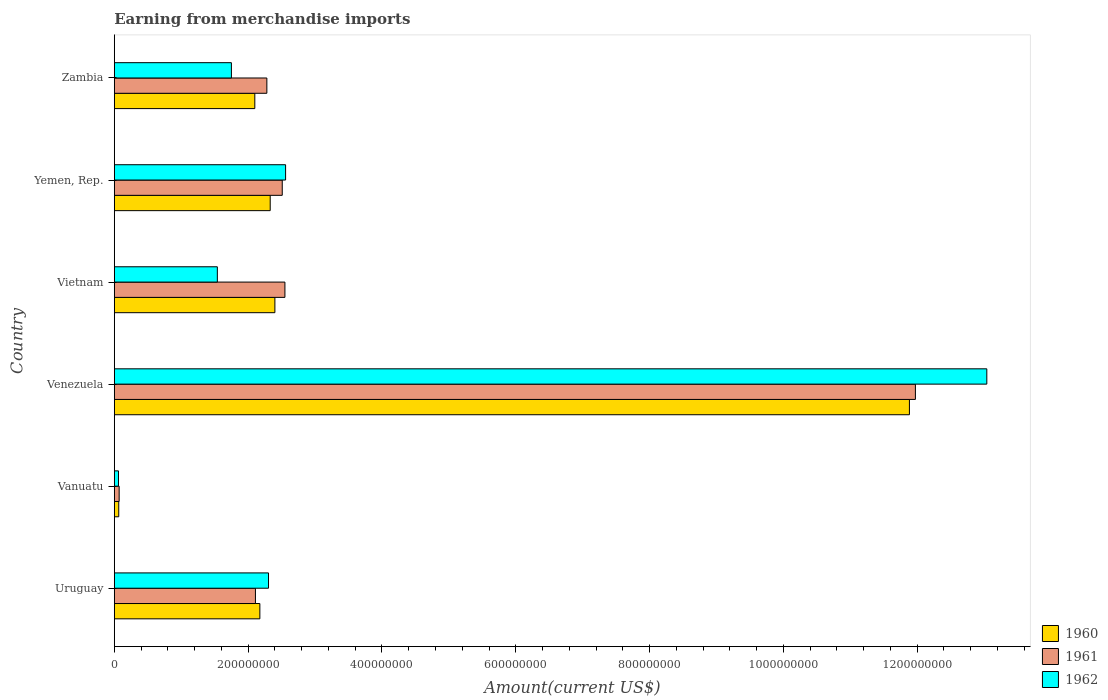How many groups of bars are there?
Your answer should be compact. 6. How many bars are there on the 4th tick from the top?
Your answer should be very brief. 3. What is the label of the 6th group of bars from the top?
Ensure brevity in your answer.  Uruguay. In how many cases, is the number of bars for a given country not equal to the number of legend labels?
Your response must be concise. 0. What is the amount earned from merchandise imports in 1962 in Vanuatu?
Offer a very short reply. 6.24e+06. Across all countries, what is the maximum amount earned from merchandise imports in 1961?
Keep it short and to the point. 1.20e+09. Across all countries, what is the minimum amount earned from merchandise imports in 1961?
Offer a very short reply. 7.25e+06. In which country was the amount earned from merchandise imports in 1961 maximum?
Your answer should be compact. Venezuela. In which country was the amount earned from merchandise imports in 1962 minimum?
Your answer should be compact. Vanuatu. What is the total amount earned from merchandise imports in 1962 in the graph?
Offer a terse response. 2.13e+09. What is the difference between the amount earned from merchandise imports in 1961 in Vietnam and that in Zambia?
Your response must be concise. 2.70e+07. What is the difference between the amount earned from merchandise imports in 1961 in Vietnam and the amount earned from merchandise imports in 1960 in Uruguay?
Make the answer very short. 3.75e+07. What is the average amount earned from merchandise imports in 1961 per country?
Your response must be concise. 3.58e+08. What is the difference between the amount earned from merchandise imports in 1960 and amount earned from merchandise imports in 1962 in Vanuatu?
Keep it short and to the point. 4.04e+05. In how many countries, is the amount earned from merchandise imports in 1962 greater than 240000000 US$?
Ensure brevity in your answer.  2. What is the ratio of the amount earned from merchandise imports in 1960 in Uruguay to that in Venezuela?
Offer a terse response. 0.18. Is the difference between the amount earned from merchandise imports in 1960 in Vanuatu and Vietnam greater than the difference between the amount earned from merchandise imports in 1962 in Vanuatu and Vietnam?
Your answer should be compact. No. What is the difference between the highest and the second highest amount earned from merchandise imports in 1962?
Your answer should be compact. 1.05e+09. What is the difference between the highest and the lowest amount earned from merchandise imports in 1961?
Offer a very short reply. 1.19e+09. In how many countries, is the amount earned from merchandise imports in 1962 greater than the average amount earned from merchandise imports in 1962 taken over all countries?
Provide a succinct answer. 1. What does the 3rd bar from the top in Venezuela represents?
Provide a short and direct response. 1960. Is it the case that in every country, the sum of the amount earned from merchandise imports in 1962 and amount earned from merchandise imports in 1960 is greater than the amount earned from merchandise imports in 1961?
Make the answer very short. Yes. Are all the bars in the graph horizontal?
Provide a succinct answer. Yes. What is the difference between two consecutive major ticks on the X-axis?
Make the answer very short. 2.00e+08. Are the values on the major ticks of X-axis written in scientific E-notation?
Offer a terse response. No. Does the graph contain any zero values?
Ensure brevity in your answer.  No. Does the graph contain grids?
Offer a very short reply. No. How are the legend labels stacked?
Offer a terse response. Vertical. What is the title of the graph?
Ensure brevity in your answer.  Earning from merchandise imports. Does "1986" appear as one of the legend labels in the graph?
Ensure brevity in your answer.  No. What is the label or title of the X-axis?
Make the answer very short. Amount(current US$). What is the Amount(current US$) in 1960 in Uruguay?
Keep it short and to the point. 2.18e+08. What is the Amount(current US$) in 1961 in Uruguay?
Your answer should be compact. 2.11e+08. What is the Amount(current US$) of 1962 in Uruguay?
Offer a terse response. 2.30e+08. What is the Amount(current US$) of 1960 in Vanuatu?
Provide a succinct answer. 6.64e+06. What is the Amount(current US$) in 1961 in Vanuatu?
Keep it short and to the point. 7.25e+06. What is the Amount(current US$) in 1962 in Vanuatu?
Your response must be concise. 6.24e+06. What is the Amount(current US$) of 1960 in Venezuela?
Keep it short and to the point. 1.19e+09. What is the Amount(current US$) of 1961 in Venezuela?
Offer a terse response. 1.20e+09. What is the Amount(current US$) in 1962 in Venezuela?
Give a very brief answer. 1.30e+09. What is the Amount(current US$) of 1960 in Vietnam?
Your response must be concise. 2.40e+08. What is the Amount(current US$) of 1961 in Vietnam?
Provide a short and direct response. 2.55e+08. What is the Amount(current US$) in 1962 in Vietnam?
Your answer should be very brief. 1.54e+08. What is the Amount(current US$) in 1960 in Yemen, Rep.?
Offer a terse response. 2.33e+08. What is the Amount(current US$) of 1961 in Yemen, Rep.?
Your answer should be very brief. 2.51e+08. What is the Amount(current US$) of 1962 in Yemen, Rep.?
Offer a very short reply. 2.56e+08. What is the Amount(current US$) in 1960 in Zambia?
Your response must be concise. 2.10e+08. What is the Amount(current US$) in 1961 in Zambia?
Give a very brief answer. 2.28e+08. What is the Amount(current US$) in 1962 in Zambia?
Keep it short and to the point. 1.75e+08. Across all countries, what is the maximum Amount(current US$) of 1960?
Offer a very short reply. 1.19e+09. Across all countries, what is the maximum Amount(current US$) of 1961?
Provide a short and direct response. 1.20e+09. Across all countries, what is the maximum Amount(current US$) in 1962?
Your answer should be compact. 1.30e+09. Across all countries, what is the minimum Amount(current US$) of 1960?
Your answer should be compact. 6.64e+06. Across all countries, what is the minimum Amount(current US$) of 1961?
Your response must be concise. 7.25e+06. Across all countries, what is the minimum Amount(current US$) in 1962?
Your answer should be compact. 6.24e+06. What is the total Amount(current US$) in 1960 in the graph?
Give a very brief answer. 2.10e+09. What is the total Amount(current US$) in 1961 in the graph?
Ensure brevity in your answer.  2.15e+09. What is the total Amount(current US$) in 1962 in the graph?
Ensure brevity in your answer.  2.13e+09. What is the difference between the Amount(current US$) in 1960 in Uruguay and that in Vanuatu?
Give a very brief answer. 2.11e+08. What is the difference between the Amount(current US$) of 1961 in Uruguay and that in Vanuatu?
Make the answer very short. 2.04e+08. What is the difference between the Amount(current US$) of 1962 in Uruguay and that in Vanuatu?
Your answer should be very brief. 2.24e+08. What is the difference between the Amount(current US$) of 1960 in Uruguay and that in Venezuela?
Your response must be concise. -9.71e+08. What is the difference between the Amount(current US$) in 1961 in Uruguay and that in Venezuela?
Ensure brevity in your answer.  -9.86e+08. What is the difference between the Amount(current US$) of 1962 in Uruguay and that in Venezuela?
Offer a very short reply. -1.07e+09. What is the difference between the Amount(current US$) of 1960 in Uruguay and that in Vietnam?
Ensure brevity in your answer.  -2.25e+07. What is the difference between the Amount(current US$) in 1961 in Uruguay and that in Vietnam?
Give a very brief answer. -4.41e+07. What is the difference between the Amount(current US$) in 1962 in Uruguay and that in Vietnam?
Keep it short and to the point. 7.65e+07. What is the difference between the Amount(current US$) of 1960 in Uruguay and that in Yemen, Rep.?
Your answer should be compact. -1.55e+07. What is the difference between the Amount(current US$) in 1961 in Uruguay and that in Yemen, Rep.?
Your response must be concise. -4.01e+07. What is the difference between the Amount(current US$) of 1962 in Uruguay and that in Yemen, Rep.?
Provide a short and direct response. -2.55e+07. What is the difference between the Amount(current US$) of 1960 in Uruguay and that in Zambia?
Offer a terse response. 7.54e+06. What is the difference between the Amount(current US$) in 1961 in Uruguay and that in Zambia?
Your answer should be compact. -1.71e+07. What is the difference between the Amount(current US$) of 1962 in Uruguay and that in Zambia?
Keep it short and to the point. 5.55e+07. What is the difference between the Amount(current US$) in 1960 in Vanuatu and that in Venezuela?
Keep it short and to the point. -1.18e+09. What is the difference between the Amount(current US$) in 1961 in Vanuatu and that in Venezuela?
Ensure brevity in your answer.  -1.19e+09. What is the difference between the Amount(current US$) of 1962 in Vanuatu and that in Venezuela?
Give a very brief answer. -1.30e+09. What is the difference between the Amount(current US$) in 1960 in Vanuatu and that in Vietnam?
Make the answer very short. -2.33e+08. What is the difference between the Amount(current US$) in 1961 in Vanuatu and that in Vietnam?
Your answer should be very brief. -2.48e+08. What is the difference between the Amount(current US$) of 1962 in Vanuatu and that in Vietnam?
Ensure brevity in your answer.  -1.48e+08. What is the difference between the Amount(current US$) of 1960 in Vanuatu and that in Yemen, Rep.?
Keep it short and to the point. -2.26e+08. What is the difference between the Amount(current US$) of 1961 in Vanuatu and that in Yemen, Rep.?
Provide a short and direct response. -2.44e+08. What is the difference between the Amount(current US$) of 1962 in Vanuatu and that in Yemen, Rep.?
Ensure brevity in your answer.  -2.50e+08. What is the difference between the Amount(current US$) of 1960 in Vanuatu and that in Zambia?
Your response must be concise. -2.03e+08. What is the difference between the Amount(current US$) of 1961 in Vanuatu and that in Zambia?
Your answer should be compact. -2.21e+08. What is the difference between the Amount(current US$) of 1962 in Vanuatu and that in Zambia?
Provide a succinct answer. -1.69e+08. What is the difference between the Amount(current US$) of 1960 in Venezuela and that in Vietnam?
Give a very brief answer. 9.48e+08. What is the difference between the Amount(current US$) of 1961 in Venezuela and that in Vietnam?
Offer a terse response. 9.42e+08. What is the difference between the Amount(current US$) in 1962 in Venezuela and that in Vietnam?
Keep it short and to the point. 1.15e+09. What is the difference between the Amount(current US$) of 1960 in Venezuela and that in Yemen, Rep.?
Offer a terse response. 9.55e+08. What is the difference between the Amount(current US$) of 1961 in Venezuela and that in Yemen, Rep.?
Provide a succinct answer. 9.46e+08. What is the difference between the Amount(current US$) of 1962 in Venezuela and that in Yemen, Rep.?
Ensure brevity in your answer.  1.05e+09. What is the difference between the Amount(current US$) in 1960 in Venezuela and that in Zambia?
Offer a very short reply. 9.78e+08. What is the difference between the Amount(current US$) of 1961 in Venezuela and that in Zambia?
Provide a succinct answer. 9.69e+08. What is the difference between the Amount(current US$) in 1962 in Venezuela and that in Zambia?
Ensure brevity in your answer.  1.13e+09. What is the difference between the Amount(current US$) in 1960 in Vietnam and that in Yemen, Rep.?
Offer a very short reply. 7.00e+06. What is the difference between the Amount(current US$) of 1961 in Vietnam and that in Yemen, Rep.?
Your answer should be very brief. 4.00e+06. What is the difference between the Amount(current US$) in 1962 in Vietnam and that in Yemen, Rep.?
Give a very brief answer. -1.02e+08. What is the difference between the Amount(current US$) of 1960 in Vietnam and that in Zambia?
Provide a succinct answer. 3.00e+07. What is the difference between the Amount(current US$) in 1961 in Vietnam and that in Zambia?
Your answer should be compact. 2.70e+07. What is the difference between the Amount(current US$) in 1962 in Vietnam and that in Zambia?
Keep it short and to the point. -2.10e+07. What is the difference between the Amount(current US$) in 1960 in Yemen, Rep. and that in Zambia?
Offer a terse response. 2.30e+07. What is the difference between the Amount(current US$) of 1961 in Yemen, Rep. and that in Zambia?
Offer a terse response. 2.30e+07. What is the difference between the Amount(current US$) in 1962 in Yemen, Rep. and that in Zambia?
Give a very brief answer. 8.10e+07. What is the difference between the Amount(current US$) of 1960 in Uruguay and the Amount(current US$) of 1961 in Vanuatu?
Your response must be concise. 2.10e+08. What is the difference between the Amount(current US$) of 1960 in Uruguay and the Amount(current US$) of 1962 in Vanuatu?
Your response must be concise. 2.11e+08. What is the difference between the Amount(current US$) of 1961 in Uruguay and the Amount(current US$) of 1962 in Vanuatu?
Your response must be concise. 2.05e+08. What is the difference between the Amount(current US$) of 1960 in Uruguay and the Amount(current US$) of 1961 in Venezuela?
Offer a terse response. -9.80e+08. What is the difference between the Amount(current US$) of 1960 in Uruguay and the Amount(current US$) of 1962 in Venezuela?
Provide a succinct answer. -1.09e+09. What is the difference between the Amount(current US$) of 1961 in Uruguay and the Amount(current US$) of 1962 in Venezuela?
Ensure brevity in your answer.  -1.09e+09. What is the difference between the Amount(current US$) of 1960 in Uruguay and the Amount(current US$) of 1961 in Vietnam?
Your answer should be very brief. -3.75e+07. What is the difference between the Amount(current US$) of 1960 in Uruguay and the Amount(current US$) of 1962 in Vietnam?
Give a very brief answer. 6.35e+07. What is the difference between the Amount(current US$) in 1961 in Uruguay and the Amount(current US$) in 1962 in Vietnam?
Keep it short and to the point. 5.69e+07. What is the difference between the Amount(current US$) in 1960 in Uruguay and the Amount(current US$) in 1961 in Yemen, Rep.?
Offer a terse response. -3.35e+07. What is the difference between the Amount(current US$) in 1960 in Uruguay and the Amount(current US$) in 1962 in Yemen, Rep.?
Ensure brevity in your answer.  -3.85e+07. What is the difference between the Amount(current US$) in 1961 in Uruguay and the Amount(current US$) in 1962 in Yemen, Rep.?
Ensure brevity in your answer.  -4.51e+07. What is the difference between the Amount(current US$) of 1960 in Uruguay and the Amount(current US$) of 1961 in Zambia?
Provide a succinct answer. -1.05e+07. What is the difference between the Amount(current US$) of 1960 in Uruguay and the Amount(current US$) of 1962 in Zambia?
Make the answer very short. 4.25e+07. What is the difference between the Amount(current US$) of 1961 in Uruguay and the Amount(current US$) of 1962 in Zambia?
Offer a terse response. 3.59e+07. What is the difference between the Amount(current US$) in 1960 in Vanuatu and the Amount(current US$) in 1961 in Venezuela?
Provide a succinct answer. -1.19e+09. What is the difference between the Amount(current US$) in 1960 in Vanuatu and the Amount(current US$) in 1962 in Venezuela?
Your response must be concise. -1.30e+09. What is the difference between the Amount(current US$) of 1961 in Vanuatu and the Amount(current US$) of 1962 in Venezuela?
Provide a succinct answer. -1.30e+09. What is the difference between the Amount(current US$) of 1960 in Vanuatu and the Amount(current US$) of 1961 in Vietnam?
Make the answer very short. -2.48e+08. What is the difference between the Amount(current US$) in 1960 in Vanuatu and the Amount(current US$) in 1962 in Vietnam?
Offer a terse response. -1.47e+08. What is the difference between the Amount(current US$) in 1961 in Vanuatu and the Amount(current US$) in 1962 in Vietnam?
Provide a short and direct response. -1.47e+08. What is the difference between the Amount(current US$) in 1960 in Vanuatu and the Amount(current US$) in 1961 in Yemen, Rep.?
Your response must be concise. -2.44e+08. What is the difference between the Amount(current US$) in 1960 in Vanuatu and the Amount(current US$) in 1962 in Yemen, Rep.?
Keep it short and to the point. -2.49e+08. What is the difference between the Amount(current US$) of 1961 in Vanuatu and the Amount(current US$) of 1962 in Yemen, Rep.?
Your answer should be compact. -2.49e+08. What is the difference between the Amount(current US$) in 1960 in Vanuatu and the Amount(current US$) in 1961 in Zambia?
Offer a terse response. -2.21e+08. What is the difference between the Amount(current US$) of 1960 in Vanuatu and the Amount(current US$) of 1962 in Zambia?
Make the answer very short. -1.68e+08. What is the difference between the Amount(current US$) of 1961 in Vanuatu and the Amount(current US$) of 1962 in Zambia?
Offer a very short reply. -1.68e+08. What is the difference between the Amount(current US$) of 1960 in Venezuela and the Amount(current US$) of 1961 in Vietnam?
Provide a succinct answer. 9.33e+08. What is the difference between the Amount(current US$) in 1960 in Venezuela and the Amount(current US$) in 1962 in Vietnam?
Give a very brief answer. 1.03e+09. What is the difference between the Amount(current US$) in 1961 in Venezuela and the Amount(current US$) in 1962 in Vietnam?
Give a very brief answer. 1.04e+09. What is the difference between the Amount(current US$) in 1960 in Venezuela and the Amount(current US$) in 1961 in Yemen, Rep.?
Offer a very short reply. 9.37e+08. What is the difference between the Amount(current US$) of 1960 in Venezuela and the Amount(current US$) of 1962 in Yemen, Rep.?
Your answer should be compact. 9.32e+08. What is the difference between the Amount(current US$) of 1961 in Venezuela and the Amount(current US$) of 1962 in Yemen, Rep.?
Offer a very short reply. 9.41e+08. What is the difference between the Amount(current US$) of 1960 in Venezuela and the Amount(current US$) of 1961 in Zambia?
Provide a short and direct response. 9.60e+08. What is the difference between the Amount(current US$) of 1960 in Venezuela and the Amount(current US$) of 1962 in Zambia?
Your answer should be compact. 1.01e+09. What is the difference between the Amount(current US$) in 1961 in Venezuela and the Amount(current US$) in 1962 in Zambia?
Your response must be concise. 1.02e+09. What is the difference between the Amount(current US$) in 1960 in Vietnam and the Amount(current US$) in 1961 in Yemen, Rep.?
Ensure brevity in your answer.  -1.10e+07. What is the difference between the Amount(current US$) of 1960 in Vietnam and the Amount(current US$) of 1962 in Yemen, Rep.?
Provide a succinct answer. -1.60e+07. What is the difference between the Amount(current US$) of 1960 in Vietnam and the Amount(current US$) of 1962 in Zambia?
Provide a succinct answer. 6.50e+07. What is the difference between the Amount(current US$) of 1961 in Vietnam and the Amount(current US$) of 1962 in Zambia?
Keep it short and to the point. 8.00e+07. What is the difference between the Amount(current US$) of 1960 in Yemen, Rep. and the Amount(current US$) of 1962 in Zambia?
Your answer should be very brief. 5.80e+07. What is the difference between the Amount(current US$) of 1961 in Yemen, Rep. and the Amount(current US$) of 1962 in Zambia?
Keep it short and to the point. 7.60e+07. What is the average Amount(current US$) of 1960 per country?
Ensure brevity in your answer.  3.49e+08. What is the average Amount(current US$) in 1961 per country?
Your answer should be compact. 3.58e+08. What is the average Amount(current US$) of 1962 per country?
Your answer should be compact. 3.54e+08. What is the difference between the Amount(current US$) of 1960 and Amount(current US$) of 1961 in Uruguay?
Give a very brief answer. 6.61e+06. What is the difference between the Amount(current US$) of 1960 and Amount(current US$) of 1962 in Uruguay?
Ensure brevity in your answer.  -1.29e+07. What is the difference between the Amount(current US$) in 1961 and Amount(current US$) in 1962 in Uruguay?
Make the answer very short. -1.96e+07. What is the difference between the Amount(current US$) in 1960 and Amount(current US$) in 1961 in Vanuatu?
Keep it short and to the point. -6.06e+05. What is the difference between the Amount(current US$) in 1960 and Amount(current US$) in 1962 in Vanuatu?
Your answer should be compact. 4.04e+05. What is the difference between the Amount(current US$) in 1961 and Amount(current US$) in 1962 in Vanuatu?
Make the answer very short. 1.01e+06. What is the difference between the Amount(current US$) of 1960 and Amount(current US$) of 1961 in Venezuela?
Provide a short and direct response. -8.95e+06. What is the difference between the Amount(current US$) in 1960 and Amount(current US$) in 1962 in Venezuela?
Your answer should be very brief. -1.16e+08. What is the difference between the Amount(current US$) in 1961 and Amount(current US$) in 1962 in Venezuela?
Give a very brief answer. -1.07e+08. What is the difference between the Amount(current US$) in 1960 and Amount(current US$) in 1961 in Vietnam?
Provide a succinct answer. -1.50e+07. What is the difference between the Amount(current US$) in 1960 and Amount(current US$) in 1962 in Vietnam?
Give a very brief answer. 8.60e+07. What is the difference between the Amount(current US$) of 1961 and Amount(current US$) of 1962 in Vietnam?
Ensure brevity in your answer.  1.01e+08. What is the difference between the Amount(current US$) of 1960 and Amount(current US$) of 1961 in Yemen, Rep.?
Your answer should be very brief. -1.80e+07. What is the difference between the Amount(current US$) of 1960 and Amount(current US$) of 1962 in Yemen, Rep.?
Your answer should be very brief. -2.30e+07. What is the difference between the Amount(current US$) of 1961 and Amount(current US$) of 1962 in Yemen, Rep.?
Provide a succinct answer. -5.00e+06. What is the difference between the Amount(current US$) in 1960 and Amount(current US$) in 1961 in Zambia?
Give a very brief answer. -1.80e+07. What is the difference between the Amount(current US$) in 1960 and Amount(current US$) in 1962 in Zambia?
Your answer should be compact. 3.50e+07. What is the difference between the Amount(current US$) of 1961 and Amount(current US$) of 1962 in Zambia?
Your answer should be compact. 5.30e+07. What is the ratio of the Amount(current US$) in 1960 in Uruguay to that in Vanuatu?
Offer a very short reply. 32.76. What is the ratio of the Amount(current US$) in 1961 in Uruguay to that in Vanuatu?
Give a very brief answer. 29.11. What is the ratio of the Amount(current US$) of 1962 in Uruguay to that in Vanuatu?
Offer a very short reply. 36.96. What is the ratio of the Amount(current US$) of 1960 in Uruguay to that in Venezuela?
Your answer should be very brief. 0.18. What is the ratio of the Amount(current US$) of 1961 in Uruguay to that in Venezuela?
Offer a terse response. 0.18. What is the ratio of the Amount(current US$) of 1962 in Uruguay to that in Venezuela?
Make the answer very short. 0.18. What is the ratio of the Amount(current US$) in 1960 in Uruguay to that in Vietnam?
Your answer should be very brief. 0.91. What is the ratio of the Amount(current US$) of 1961 in Uruguay to that in Vietnam?
Offer a terse response. 0.83. What is the ratio of the Amount(current US$) in 1962 in Uruguay to that in Vietnam?
Your answer should be compact. 1.5. What is the ratio of the Amount(current US$) in 1960 in Uruguay to that in Yemen, Rep.?
Offer a terse response. 0.93. What is the ratio of the Amount(current US$) in 1961 in Uruguay to that in Yemen, Rep.?
Your answer should be very brief. 0.84. What is the ratio of the Amount(current US$) of 1962 in Uruguay to that in Yemen, Rep.?
Your answer should be very brief. 0.9. What is the ratio of the Amount(current US$) of 1960 in Uruguay to that in Zambia?
Offer a very short reply. 1.04. What is the ratio of the Amount(current US$) in 1961 in Uruguay to that in Zambia?
Ensure brevity in your answer.  0.93. What is the ratio of the Amount(current US$) of 1962 in Uruguay to that in Zambia?
Provide a succinct answer. 1.32. What is the ratio of the Amount(current US$) in 1960 in Vanuatu to that in Venezuela?
Make the answer very short. 0.01. What is the ratio of the Amount(current US$) in 1961 in Vanuatu to that in Venezuela?
Your answer should be very brief. 0.01. What is the ratio of the Amount(current US$) of 1962 in Vanuatu to that in Venezuela?
Provide a short and direct response. 0. What is the ratio of the Amount(current US$) of 1960 in Vanuatu to that in Vietnam?
Give a very brief answer. 0.03. What is the ratio of the Amount(current US$) of 1961 in Vanuatu to that in Vietnam?
Offer a terse response. 0.03. What is the ratio of the Amount(current US$) of 1962 in Vanuatu to that in Vietnam?
Your answer should be very brief. 0.04. What is the ratio of the Amount(current US$) of 1960 in Vanuatu to that in Yemen, Rep.?
Your answer should be compact. 0.03. What is the ratio of the Amount(current US$) in 1961 in Vanuatu to that in Yemen, Rep.?
Keep it short and to the point. 0.03. What is the ratio of the Amount(current US$) in 1962 in Vanuatu to that in Yemen, Rep.?
Your answer should be compact. 0.02. What is the ratio of the Amount(current US$) in 1960 in Vanuatu to that in Zambia?
Make the answer very short. 0.03. What is the ratio of the Amount(current US$) of 1961 in Vanuatu to that in Zambia?
Make the answer very short. 0.03. What is the ratio of the Amount(current US$) of 1962 in Vanuatu to that in Zambia?
Your response must be concise. 0.04. What is the ratio of the Amount(current US$) of 1960 in Venezuela to that in Vietnam?
Your answer should be compact. 4.95. What is the ratio of the Amount(current US$) in 1961 in Venezuela to that in Vietnam?
Offer a terse response. 4.7. What is the ratio of the Amount(current US$) in 1962 in Venezuela to that in Vietnam?
Provide a short and direct response. 8.47. What is the ratio of the Amount(current US$) of 1960 in Venezuela to that in Yemen, Rep.?
Your response must be concise. 5.1. What is the ratio of the Amount(current US$) in 1961 in Venezuela to that in Yemen, Rep.?
Offer a very short reply. 4.77. What is the ratio of the Amount(current US$) in 1962 in Venezuela to that in Yemen, Rep.?
Make the answer very short. 5.09. What is the ratio of the Amount(current US$) in 1960 in Venezuela to that in Zambia?
Ensure brevity in your answer.  5.66. What is the ratio of the Amount(current US$) in 1961 in Venezuela to that in Zambia?
Provide a succinct answer. 5.25. What is the ratio of the Amount(current US$) of 1962 in Venezuela to that in Zambia?
Provide a succinct answer. 7.45. What is the ratio of the Amount(current US$) of 1961 in Vietnam to that in Yemen, Rep.?
Offer a terse response. 1.02. What is the ratio of the Amount(current US$) in 1962 in Vietnam to that in Yemen, Rep.?
Provide a short and direct response. 0.6. What is the ratio of the Amount(current US$) in 1961 in Vietnam to that in Zambia?
Give a very brief answer. 1.12. What is the ratio of the Amount(current US$) in 1962 in Vietnam to that in Zambia?
Your response must be concise. 0.88. What is the ratio of the Amount(current US$) in 1960 in Yemen, Rep. to that in Zambia?
Make the answer very short. 1.11. What is the ratio of the Amount(current US$) in 1961 in Yemen, Rep. to that in Zambia?
Provide a succinct answer. 1.1. What is the ratio of the Amount(current US$) of 1962 in Yemen, Rep. to that in Zambia?
Your answer should be very brief. 1.46. What is the difference between the highest and the second highest Amount(current US$) of 1960?
Ensure brevity in your answer.  9.48e+08. What is the difference between the highest and the second highest Amount(current US$) in 1961?
Give a very brief answer. 9.42e+08. What is the difference between the highest and the second highest Amount(current US$) of 1962?
Provide a short and direct response. 1.05e+09. What is the difference between the highest and the lowest Amount(current US$) in 1960?
Make the answer very short. 1.18e+09. What is the difference between the highest and the lowest Amount(current US$) of 1961?
Your answer should be compact. 1.19e+09. What is the difference between the highest and the lowest Amount(current US$) in 1962?
Your response must be concise. 1.30e+09. 